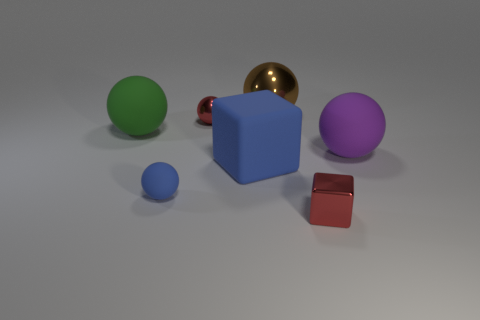Does the small thing behind the big purple ball have the same material as the tiny block?
Provide a succinct answer. Yes. What number of other objects are there of the same color as the large metal sphere?
Give a very brief answer. 0. Is the big matte cube the same color as the tiny rubber object?
Your answer should be very brief. Yes. What size is the shiny object in front of the purple sphere that is on the right side of the red metallic block?
Offer a very short reply. Small. Do the red object that is to the right of the brown object and the big sphere that is right of the large shiny sphere have the same material?
Your answer should be compact. No. Does the shiny thing to the left of the brown shiny thing have the same color as the metal block?
Offer a terse response. Yes. There is a large brown sphere; how many shiny objects are on the right side of it?
Offer a very short reply. 1. Are the big blue object and the big sphere in front of the large green rubber thing made of the same material?
Your answer should be compact. Yes. There is another blue object that is the same material as the big blue thing; what is its size?
Your response must be concise. Small. Is the number of large rubber things that are in front of the purple matte thing greater than the number of small red metallic objects to the right of the small red cube?
Ensure brevity in your answer.  Yes. 